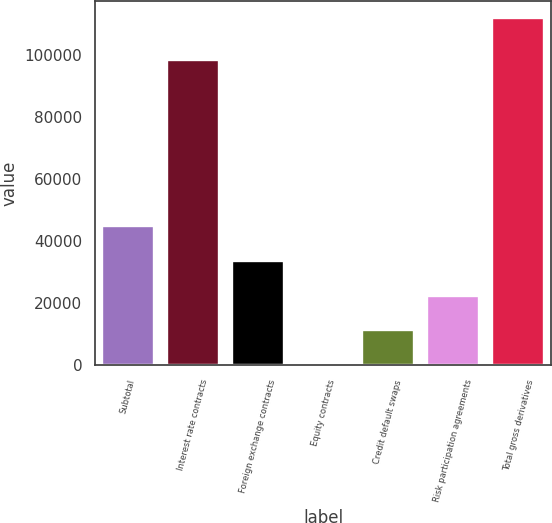<chart> <loc_0><loc_0><loc_500><loc_500><bar_chart><fcel>Subtotal<fcel>Interest rate contracts<fcel>Foreign exchange contracts<fcel>Equity contracts<fcel>Credit default swaps<fcel>Risk participation agreements<fcel>Total gross derivatives<nl><fcel>44904.4<fcel>98423<fcel>33717.3<fcel>156<fcel>11343.1<fcel>22530.2<fcel>112027<nl></chart> 